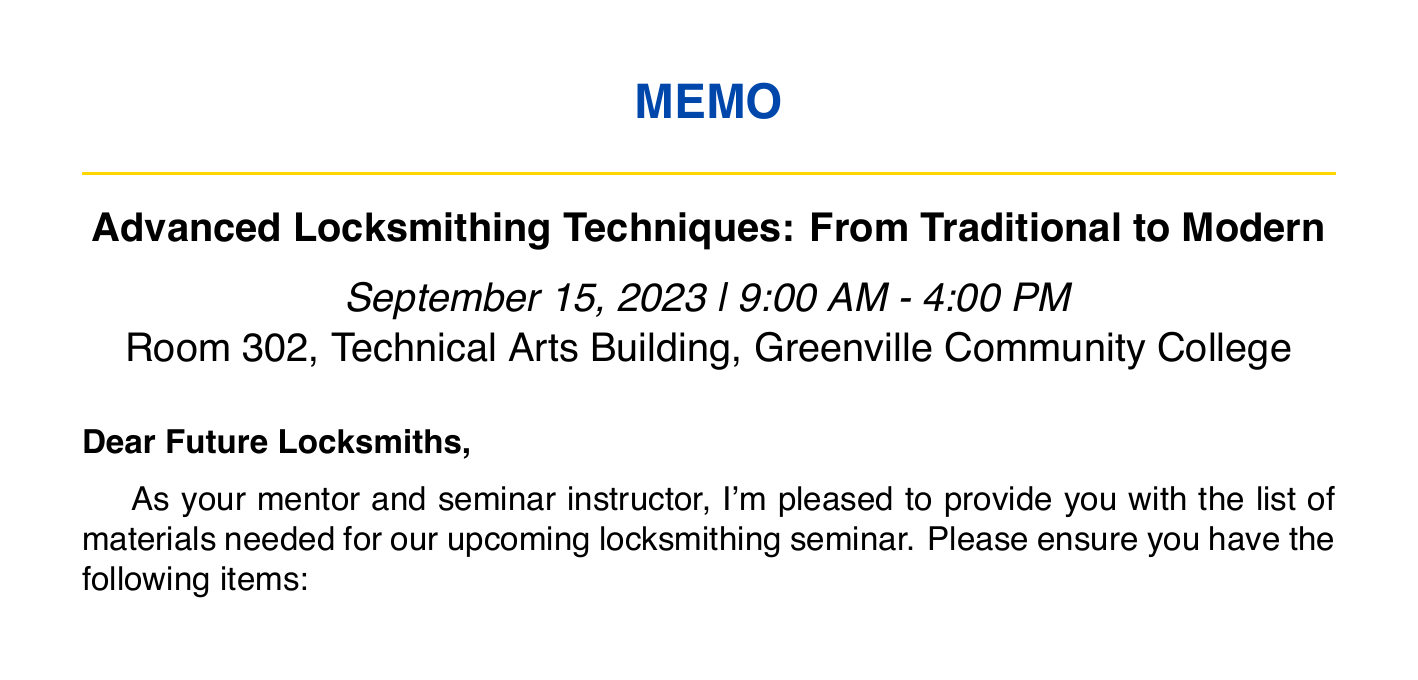What is the seminar title? The title of the seminar is explicitly mentioned in the document.
Answer: Advanced Locksmithing Techniques: From Traditional to Modern When is the seminar scheduled? The date of the seminar can be found in the seminar details.
Answer: September 15, 2023 What is one required tool for the seminar? The document lists various required tools for the seminar.
Answer: Pin tumbler lock pick set (Peterson Ghost Pro) Name one type of safety equipment listed. The document includes a section specifically for safety equipment.
Answer: Safety glasses How many demonstration locks are mentioned? The number of different demonstration locks can be counted from the list in the document.
Answer: Five What equipment is required for audiovisual purposes? The document specifies required audiovisual equipment, which includes multiple items.
Answer: Laptop with HDMI output What refreshments will be provided? The document lists types of refreshments that will be offered during the seminar.
Answer: Coffee and tea What will participants receive upon completion? The document mentions materials that will be provided to participants.
Answer: Certificates of completion Is there a sign-in sheet required? The document lists additional items needed which include a sign-in sheet.
Answer: Yes 